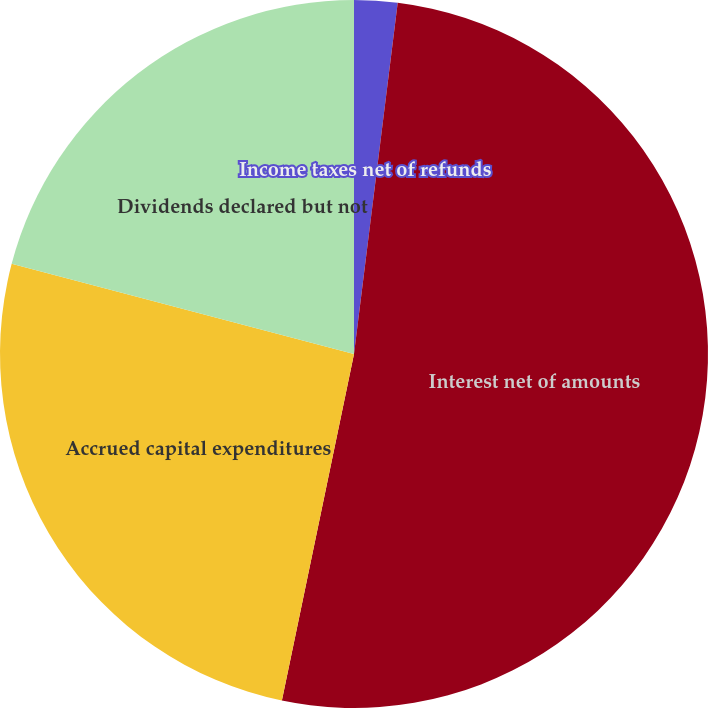Convert chart to OTSL. <chart><loc_0><loc_0><loc_500><loc_500><pie_chart><fcel>Income taxes net of refunds<fcel>Interest net of amounts<fcel>Accrued capital expenditures<fcel>Dividends declared but not<nl><fcel>1.97%<fcel>51.29%<fcel>25.83%<fcel>20.9%<nl></chart> 